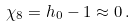Convert formula to latex. <formula><loc_0><loc_0><loc_500><loc_500>\chi _ { 8 } = h _ { 0 } - 1 \approx 0 \, .</formula> 